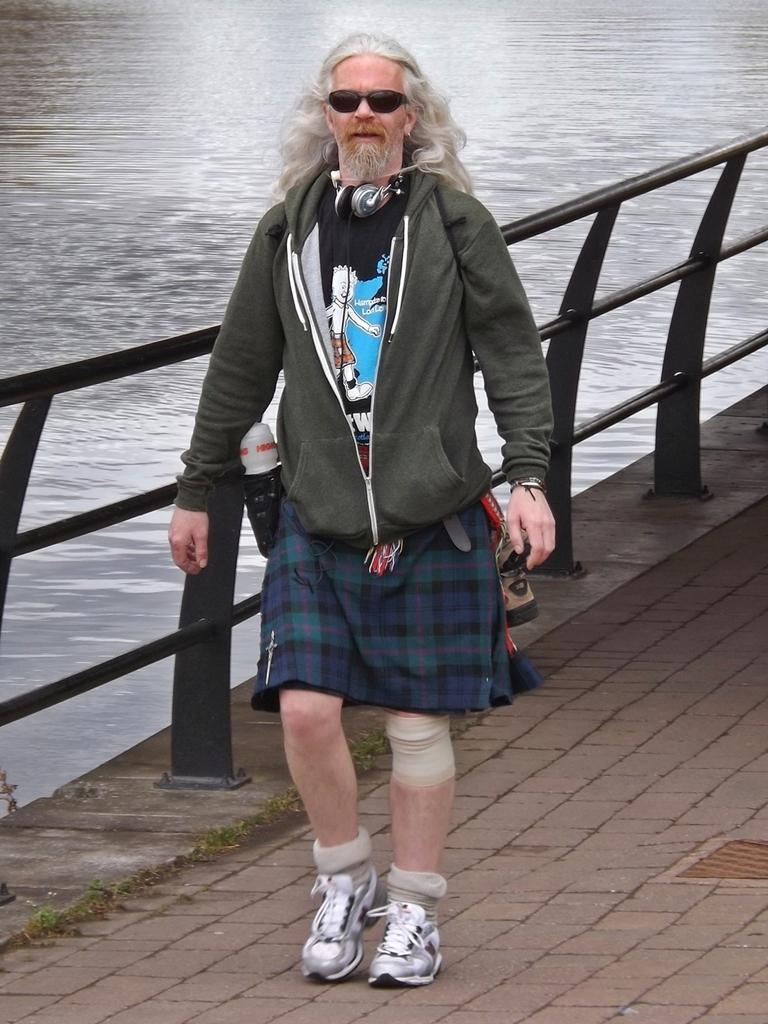What type of water body is present in the image? There is a canal in the image. What can be seen near the canal? There is a black fence in the image. What is the person in the image doing? The person is wearing some objects and walking on the road in the image. What type of vegetation is present in the image? There are small plants and grass in the image. What position does the lead hold in the image? There is no mention of a lead or any leadership role in the image. How does the person shake hands with the canal in the image? The person is not shaking hands with the canal; they are walking on the road. 